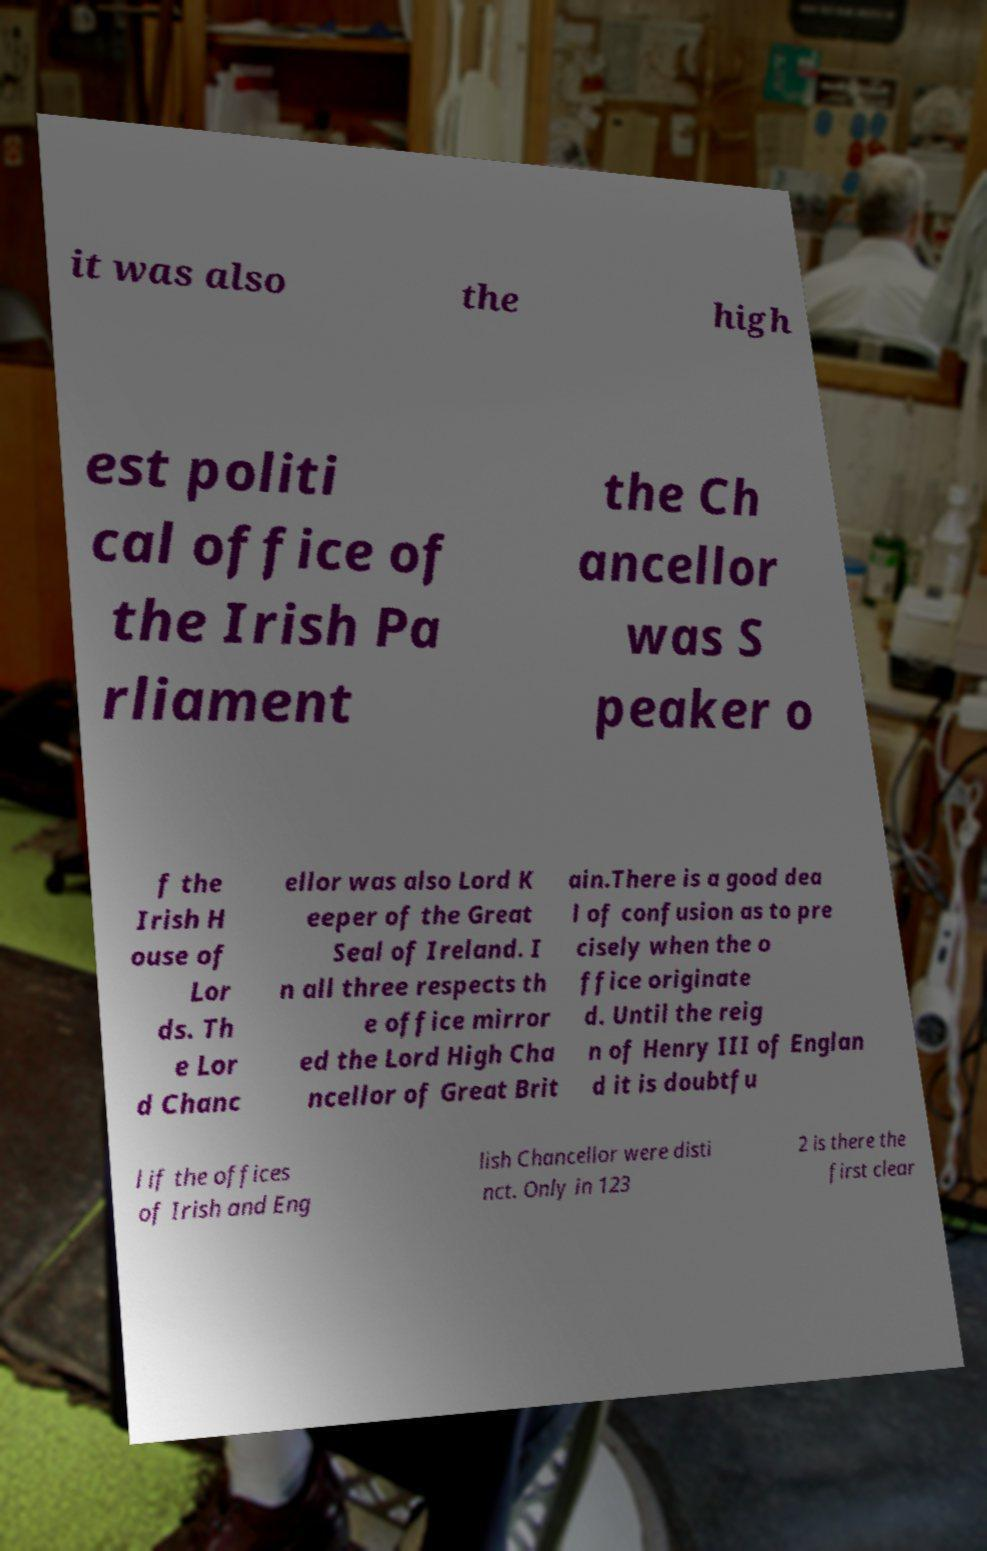What messages or text are displayed in this image? I need them in a readable, typed format. it was also the high est politi cal office of the Irish Pa rliament the Ch ancellor was S peaker o f the Irish H ouse of Lor ds. Th e Lor d Chanc ellor was also Lord K eeper of the Great Seal of Ireland. I n all three respects th e office mirror ed the Lord High Cha ncellor of Great Brit ain.There is a good dea l of confusion as to pre cisely when the o ffice originate d. Until the reig n of Henry III of Englan d it is doubtfu l if the offices of Irish and Eng lish Chancellor were disti nct. Only in 123 2 is there the first clear 